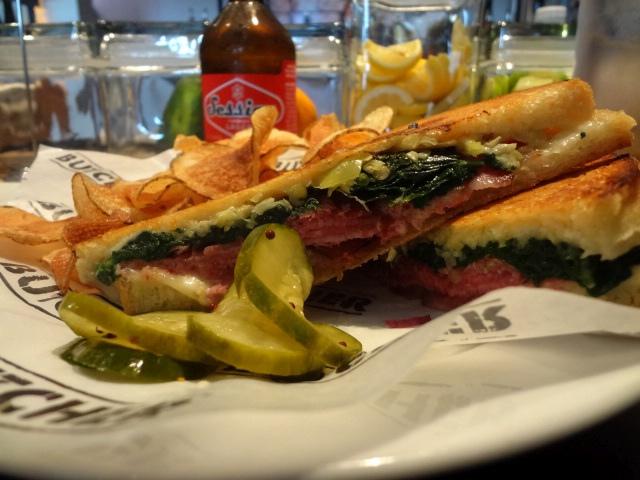Are there any French fries on the plate?
Be succinct. No. Is this a home-cooked meal?
Give a very brief answer. No. What is the main color of the label on the bottle?
Give a very brief answer. Red. What is on top of the sandwich?
Short answer required. Chips. 